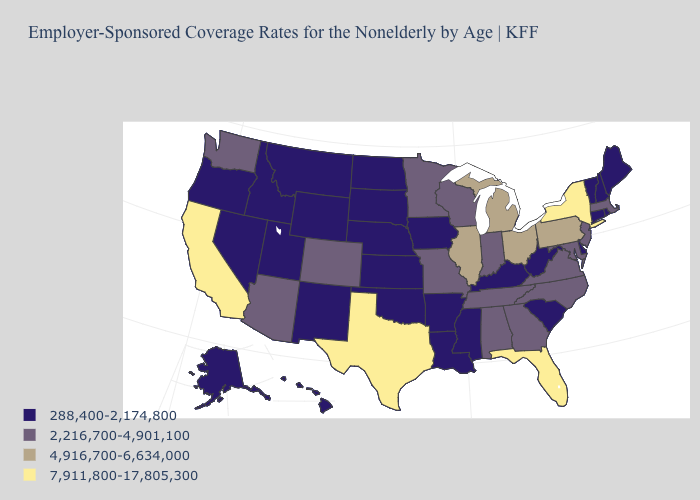What is the value of North Carolina?
Write a very short answer. 2,216,700-4,901,100. Among the states that border Delaware , does New Jersey have the lowest value?
Short answer required. Yes. Does Alabama have a lower value than Michigan?
Keep it brief. Yes. Name the states that have a value in the range 4,916,700-6,634,000?
Write a very short answer. Illinois, Michigan, Ohio, Pennsylvania. Does Utah have a higher value than Rhode Island?
Write a very short answer. No. What is the highest value in the West ?
Give a very brief answer. 7,911,800-17,805,300. Name the states that have a value in the range 2,216,700-4,901,100?
Give a very brief answer. Alabama, Arizona, Colorado, Georgia, Indiana, Maryland, Massachusetts, Minnesota, Missouri, New Jersey, North Carolina, Tennessee, Virginia, Washington, Wisconsin. What is the lowest value in the USA?
Be succinct. 288,400-2,174,800. Among the states that border South Dakota , does Wyoming have the highest value?
Be succinct. No. Is the legend a continuous bar?
Write a very short answer. No. Does Oklahoma have the highest value in the USA?
Give a very brief answer. No. Is the legend a continuous bar?
Answer briefly. No. Does Ohio have the lowest value in the USA?
Write a very short answer. No. What is the value of West Virginia?
Keep it brief. 288,400-2,174,800. Does Washington have the lowest value in the USA?
Answer briefly. No. 